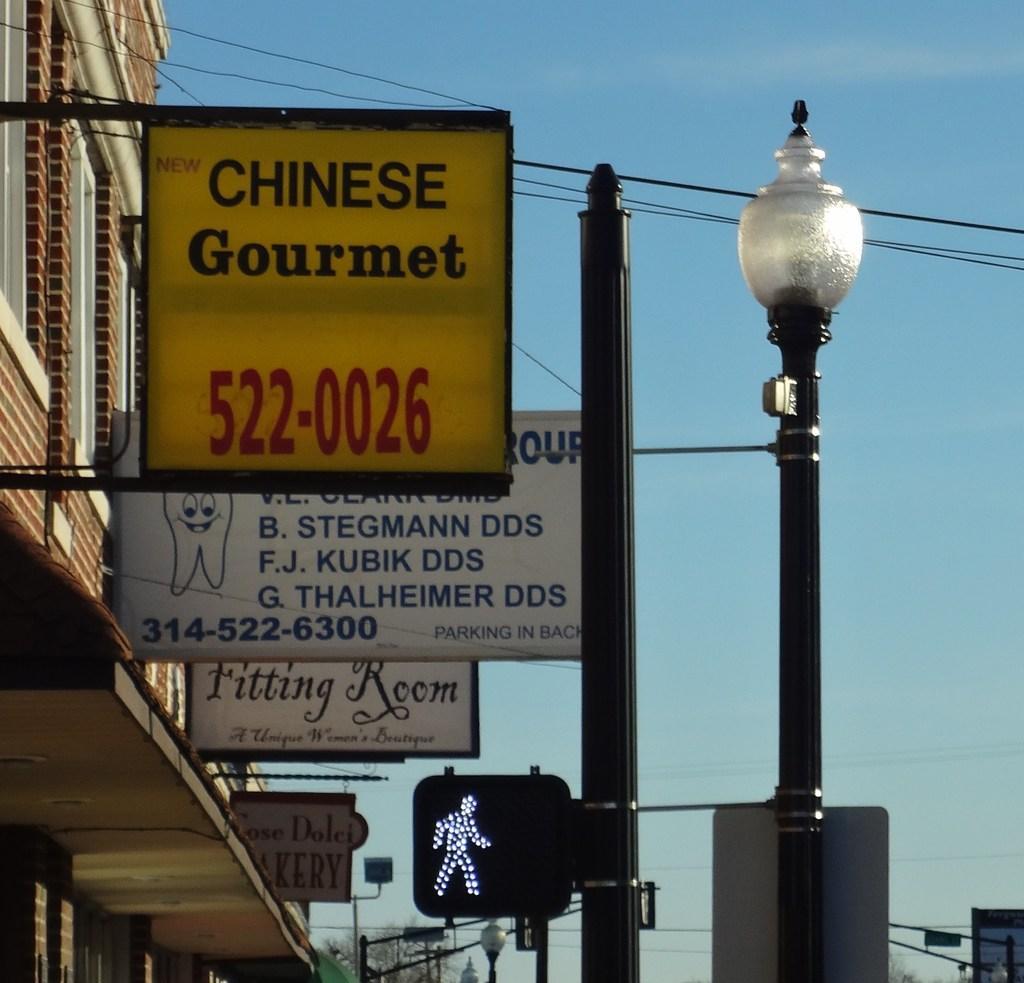Please provide a concise description of this image. In this picture we can see buildings, some boards to the poles and we can see signal light. 